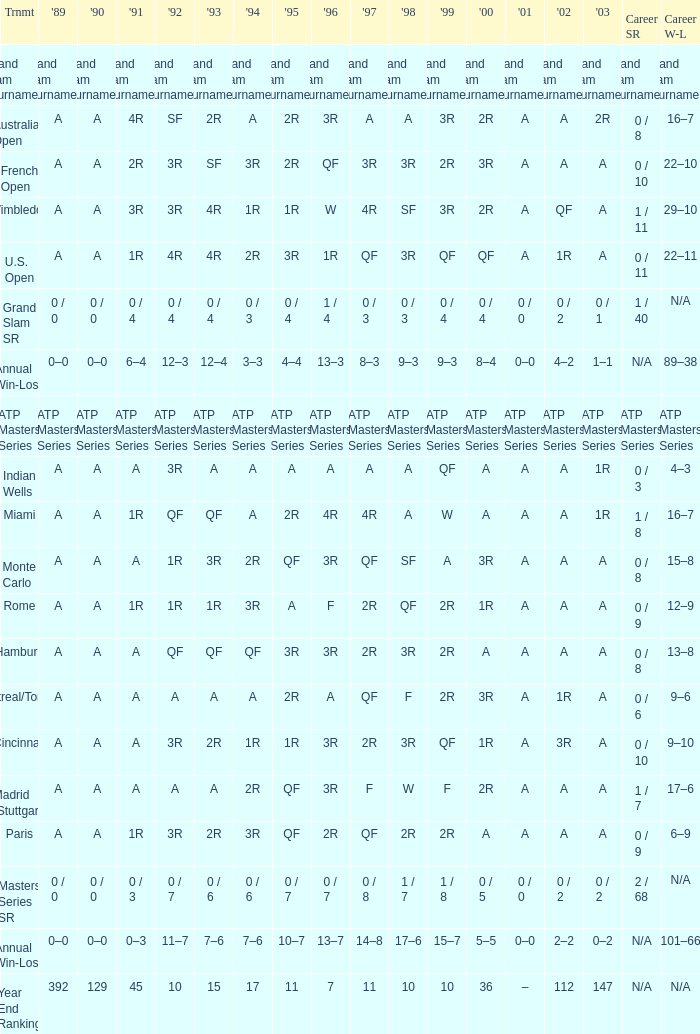Would you mind parsing the complete table? {'header': ['Trnmt', "'89", "'90", "'91", "'92", "'93", "'94", "'95", "'96", "'97", "'98", "'99", "'00", "'01", "'02", "'03", 'Career SR', 'Career W-L'], 'rows': [['Grand Slam Tournaments', 'Grand Slam Tournaments', 'Grand Slam Tournaments', 'Grand Slam Tournaments', 'Grand Slam Tournaments', 'Grand Slam Tournaments', 'Grand Slam Tournaments', 'Grand Slam Tournaments', 'Grand Slam Tournaments', 'Grand Slam Tournaments', 'Grand Slam Tournaments', 'Grand Slam Tournaments', 'Grand Slam Tournaments', 'Grand Slam Tournaments', 'Grand Slam Tournaments', 'Grand Slam Tournaments', 'Grand Slam Tournaments', 'Grand Slam Tournaments'], ['Australian Open', 'A', 'A', '4R', 'SF', '2R', 'A', '2R', '3R', 'A', 'A', '3R', '2R', 'A', 'A', '2R', '0 / 8', '16–7'], ['French Open', 'A', 'A', '2R', '3R', 'SF', '3R', '2R', 'QF', '3R', '3R', '2R', '3R', 'A', 'A', 'A', '0 / 10', '22–10'], ['Wimbledon', 'A', 'A', '3R', '3R', '4R', '1R', '1R', 'W', '4R', 'SF', '3R', '2R', 'A', 'QF', 'A', '1 / 11', '29–10'], ['U.S. Open', 'A', 'A', '1R', '4R', '4R', '2R', '3R', '1R', 'QF', '3R', 'QF', 'QF', 'A', '1R', 'A', '0 / 11', '22–11'], ['Grand Slam SR', '0 / 0', '0 / 0', '0 / 4', '0 / 4', '0 / 4', '0 / 3', '0 / 4', '1 / 4', '0 / 3', '0 / 3', '0 / 4', '0 / 4', '0 / 0', '0 / 2', '0 / 1', '1 / 40', 'N/A'], ['Annual Win-Loss', '0–0', '0–0', '6–4', '12–3', '12–4', '3–3', '4–4', '13–3', '8–3', '9–3', '9–3', '8–4', '0–0', '4–2', '1–1', 'N/A', '89–38'], ['ATP Masters Series', 'ATP Masters Series', 'ATP Masters Series', 'ATP Masters Series', 'ATP Masters Series', 'ATP Masters Series', 'ATP Masters Series', 'ATP Masters Series', 'ATP Masters Series', 'ATP Masters Series', 'ATP Masters Series', 'ATP Masters Series', 'ATP Masters Series', 'ATP Masters Series', 'ATP Masters Series', 'ATP Masters Series', 'ATP Masters Series', 'ATP Masters Series'], ['Indian Wells', 'A', 'A', 'A', '3R', 'A', 'A', 'A', 'A', 'A', 'A', 'QF', 'A', 'A', 'A', '1R', '0 / 3', '4–3'], ['Miami', 'A', 'A', '1R', 'QF', 'QF', 'A', '2R', '4R', '4R', 'A', 'W', 'A', 'A', 'A', '1R', '1 / 8', '16–7'], ['Monte Carlo', 'A', 'A', 'A', '1R', '3R', '2R', 'QF', '3R', 'QF', 'SF', 'A', '3R', 'A', 'A', 'A', '0 / 8', '15–8'], ['Rome', 'A', 'A', '1R', '1R', '1R', '3R', 'A', 'F', '2R', 'QF', '2R', '1R', 'A', 'A', 'A', '0 / 9', '12–9'], ['Hamburg', 'A', 'A', 'A', 'QF', 'QF', 'QF', '3R', '3R', '2R', '3R', '2R', 'A', 'A', 'A', 'A', '0 / 8', '13–8'], ['Montreal/Toronto', 'A', 'A', 'A', 'A', 'A', 'A', '2R', 'A', 'QF', 'F', '2R', '3R', 'A', '1R', 'A', '0 / 6', '9–6'], ['Cincinnati', 'A', 'A', 'A', '3R', '2R', '1R', '1R', '3R', '2R', '3R', 'QF', '1R', 'A', '3R', 'A', '0 / 10', '9–10'], ['Madrid (Stuttgart)', 'A', 'A', 'A', 'A', 'A', '2R', 'QF', '3R', 'F', 'W', 'F', '2R', 'A', 'A', 'A', '1 / 7', '17–6'], ['Paris', 'A', 'A', '1R', '3R', '2R', '3R', 'QF', '2R', 'QF', '2R', '2R', 'A', 'A', 'A', 'A', '0 / 9', '6–9'], ['Masters Series SR', '0 / 0', '0 / 0', '0 / 3', '0 / 7', '0 / 6', '0 / 6', '0 / 7', '0 / 7', '0 / 8', '1 / 7', '1 / 8', '0 / 5', '0 / 0', '0 / 2', '0 / 2', '2 / 68', 'N/A'], ['Annual Win-Loss', '0–0', '0–0', '0–3', '11–7', '7–6', '7–6', '10–7', '13–7', '14–8', '17–6', '15–7', '5–5', '0–0', '2–2', '0–2', 'N/A', '101–66'], ['Year End Ranking', '392', '129', '45', '10', '15', '17', '11', '7', '11', '10', '10', '36', '–', '112', '147', 'N/A', 'N/A']]} What was the value in 1995 for A in 2000 at the Indian Wells tournament? A. 